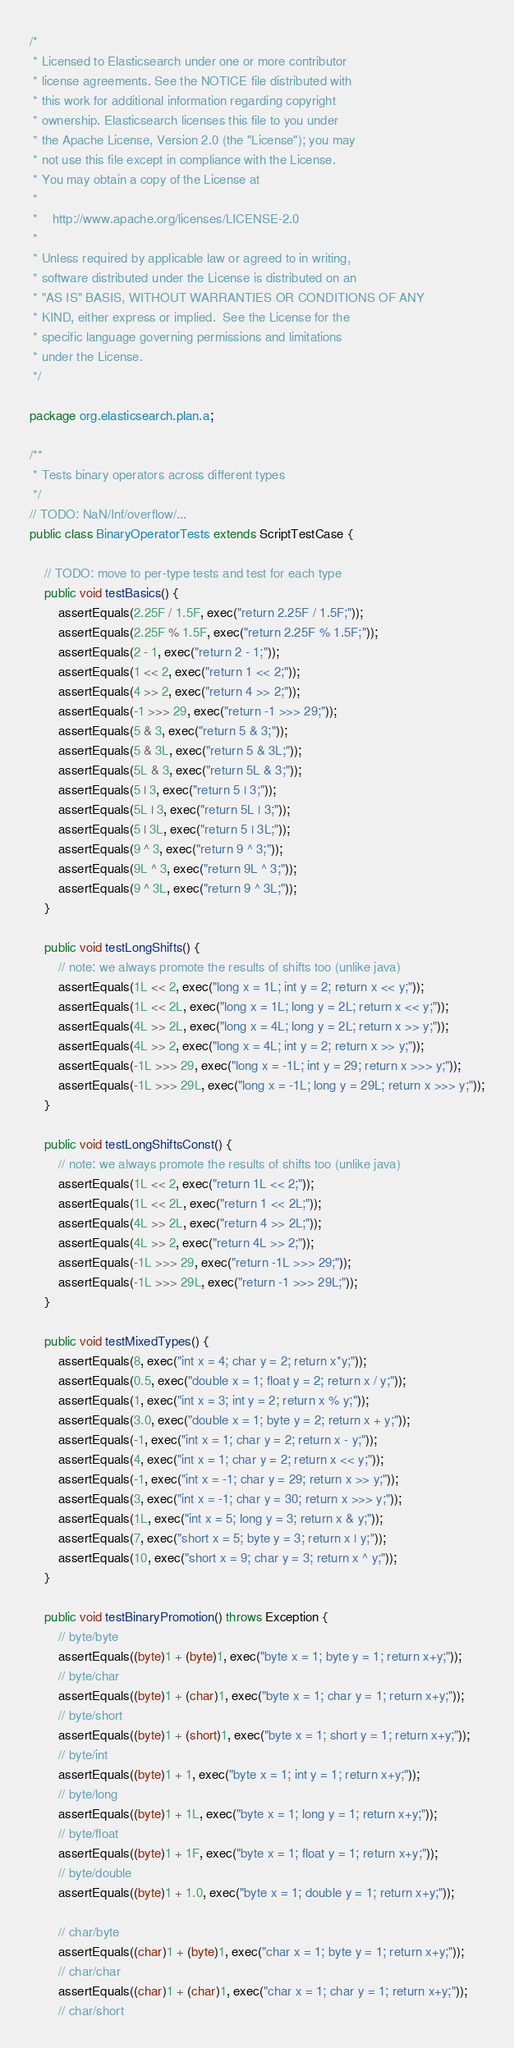<code> <loc_0><loc_0><loc_500><loc_500><_Java_>/*
 * Licensed to Elasticsearch under one or more contributor
 * license agreements. See the NOTICE file distributed with
 * this work for additional information regarding copyright
 * ownership. Elasticsearch licenses this file to you under
 * the Apache License, Version 2.0 (the "License"); you may
 * not use this file except in compliance with the License.
 * You may obtain a copy of the License at
 *
 *    http://www.apache.org/licenses/LICENSE-2.0
 *
 * Unless required by applicable law or agreed to in writing,
 * software distributed under the License is distributed on an
 * "AS IS" BASIS, WITHOUT WARRANTIES OR CONDITIONS OF ANY
 * KIND, either express or implied.  See the License for the
 * specific language governing permissions and limitations
 * under the License.
 */

package org.elasticsearch.plan.a;

/** 
 * Tests binary operators across different types
 */
// TODO: NaN/Inf/overflow/...
public class BinaryOperatorTests extends ScriptTestCase {
    
    // TODO: move to per-type tests and test for each type
    public void testBasics() {
        assertEquals(2.25F / 1.5F, exec("return 2.25F / 1.5F;"));
        assertEquals(2.25F % 1.5F, exec("return 2.25F % 1.5F;"));
        assertEquals(2 - 1, exec("return 2 - 1;"));
        assertEquals(1 << 2, exec("return 1 << 2;"));
        assertEquals(4 >> 2, exec("return 4 >> 2;"));
        assertEquals(-1 >>> 29, exec("return -1 >>> 29;"));
        assertEquals(5 & 3, exec("return 5 & 3;"));
        assertEquals(5 & 3L, exec("return 5 & 3L;"));
        assertEquals(5L & 3, exec("return 5L & 3;"));
        assertEquals(5 | 3, exec("return 5 | 3;"));
        assertEquals(5L | 3, exec("return 5L | 3;"));
        assertEquals(5 | 3L, exec("return 5 | 3L;"));
        assertEquals(9 ^ 3, exec("return 9 ^ 3;"));
        assertEquals(9L ^ 3, exec("return 9L ^ 3;"));
        assertEquals(9 ^ 3L, exec("return 9 ^ 3L;"));
    }
    
    public void testLongShifts() {
        // note: we always promote the results of shifts too (unlike java)
        assertEquals(1L << 2, exec("long x = 1L; int y = 2; return x << y;"));
        assertEquals(1L << 2L, exec("long x = 1L; long y = 2L; return x << y;"));
        assertEquals(4L >> 2L, exec("long x = 4L; long y = 2L; return x >> y;"));
        assertEquals(4L >> 2, exec("long x = 4L; int y = 2; return x >> y;"));
        assertEquals(-1L >>> 29, exec("long x = -1L; int y = 29; return x >>> y;"));
        assertEquals(-1L >>> 29L, exec("long x = -1L; long y = 29L; return x >>> y;"));
    }
    
    public void testLongShiftsConst() {
        // note: we always promote the results of shifts too (unlike java)
        assertEquals(1L << 2, exec("return 1L << 2;"));
        assertEquals(1L << 2L, exec("return 1 << 2L;"));
        assertEquals(4L >> 2L, exec("return 4 >> 2L;"));
        assertEquals(4L >> 2, exec("return 4L >> 2;"));
        assertEquals(-1L >>> 29, exec("return -1L >>> 29;"));
        assertEquals(-1L >>> 29L, exec("return -1 >>> 29L;"));
    }
    
    public void testMixedTypes() {
        assertEquals(8, exec("int x = 4; char y = 2; return x*y;"));
        assertEquals(0.5, exec("double x = 1; float y = 2; return x / y;"));
        assertEquals(1, exec("int x = 3; int y = 2; return x % y;"));
        assertEquals(3.0, exec("double x = 1; byte y = 2; return x + y;"));
        assertEquals(-1, exec("int x = 1; char y = 2; return x - y;"));
        assertEquals(4, exec("int x = 1; char y = 2; return x << y;"));
        assertEquals(-1, exec("int x = -1; char y = 29; return x >> y;"));
        assertEquals(3, exec("int x = -1; char y = 30; return x >>> y;"));
        assertEquals(1L, exec("int x = 5; long y = 3; return x & y;"));
        assertEquals(7, exec("short x = 5; byte y = 3; return x | y;"));
        assertEquals(10, exec("short x = 9; char y = 3; return x ^ y;"));
    }
    
    public void testBinaryPromotion() throws Exception {
        // byte/byte
        assertEquals((byte)1 + (byte)1, exec("byte x = 1; byte y = 1; return x+y;"));
        // byte/char
        assertEquals((byte)1 + (char)1, exec("byte x = 1; char y = 1; return x+y;"));
        // byte/short
        assertEquals((byte)1 + (short)1, exec("byte x = 1; short y = 1; return x+y;"));
        // byte/int
        assertEquals((byte)1 + 1, exec("byte x = 1; int y = 1; return x+y;"));
        // byte/long
        assertEquals((byte)1 + 1L, exec("byte x = 1; long y = 1; return x+y;"));
        // byte/float
        assertEquals((byte)1 + 1F, exec("byte x = 1; float y = 1; return x+y;"));
        // byte/double
        assertEquals((byte)1 + 1.0, exec("byte x = 1; double y = 1; return x+y;"));
        
        // char/byte
        assertEquals((char)1 + (byte)1, exec("char x = 1; byte y = 1; return x+y;"));
        // char/char
        assertEquals((char)1 + (char)1, exec("char x = 1; char y = 1; return x+y;"));
        // char/short</code> 